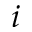<formula> <loc_0><loc_0><loc_500><loc_500>i</formula> 